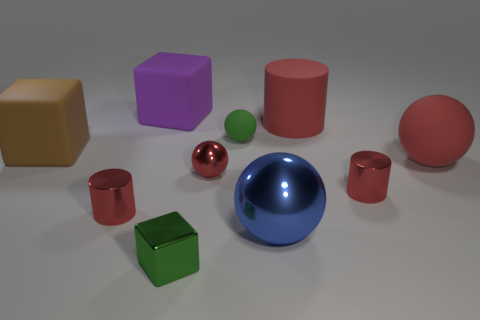Does the tiny metallic object that is to the right of the big blue thing have the same color as the tiny shiny object that is to the left of the green metallic object?
Offer a terse response. Yes. What is the material of the red sphere that is the same size as the green shiny object?
Give a very brief answer. Metal. What shape is the purple matte thing left of the matte cylinder in front of the cube that is behind the brown cube?
Give a very brief answer. Cube. There is a brown object that is the same size as the blue metallic thing; what shape is it?
Keep it short and to the point. Cube. How many red matte things are to the left of the small sphere in front of the big brown cube that is left of the tiny green matte ball?
Provide a succinct answer. 0. Is the number of large objects right of the big metallic ball greater than the number of red balls in front of the small red metal ball?
Keep it short and to the point. Yes. How many other big metallic objects are the same shape as the purple object?
Provide a short and direct response. 0. What number of objects are either small shiny objects that are on the left side of the rubber cylinder or big matte blocks that are behind the green sphere?
Keep it short and to the point. 4. What material is the tiny cylinder that is left of the small metallic cylinder that is on the right side of the thing that is behind the matte cylinder?
Offer a very short reply. Metal. Do the rubber object in front of the large brown block and the big rubber cylinder have the same color?
Provide a succinct answer. Yes. 